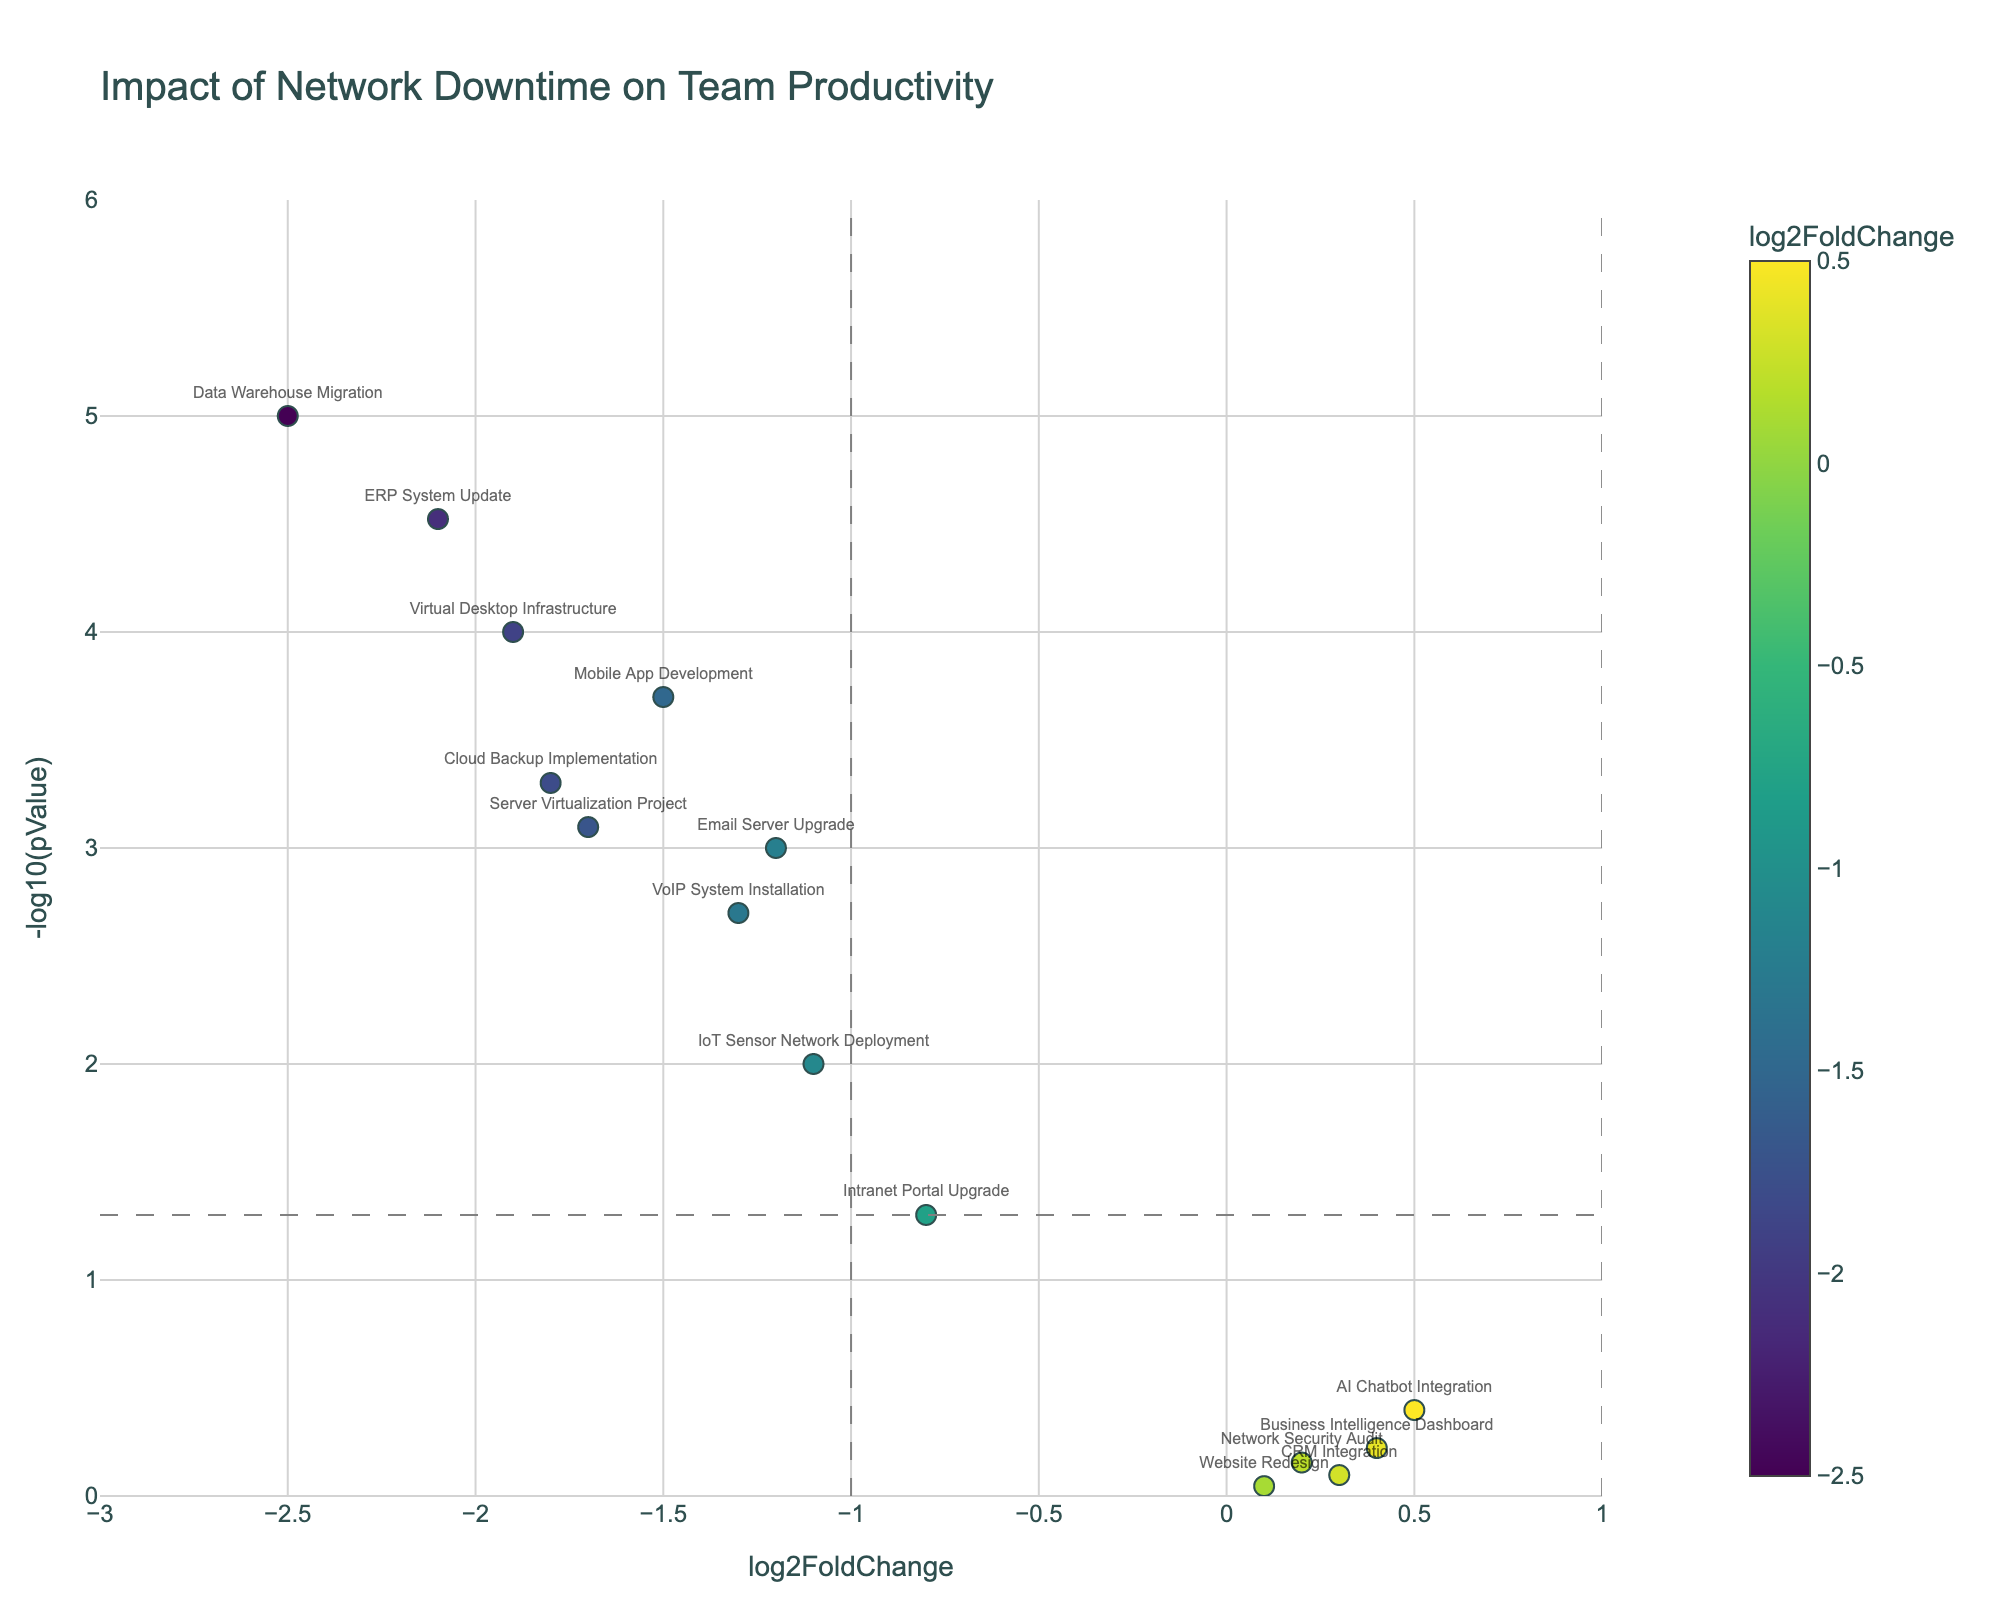How many projects are represented in the figure? Count the markers on the plot. Each marker represents one project. There are 15 markers visible on the plot.
Answer: 15 What is the title of the figure? The title is displayed at the top of the plot. It reads "Impact of Network Downtime on Team Productivity".
Answer: Impact of Network Downtime on Team Productivity Which project has the highest p-value and what is it? Look for the marker closest to the x-axis (smallest "-log10(pValue)"). The "Website Redesign" project is closest with a p-value of 0.9.
Answer: Website Redesign, 0.9 Which project shows the largest negative log2FoldChange? Identify the marker farthest to the left on the x-axis. The "Data Warehouse Migration" has the largest negative log2FoldChange at -2.5.
Answer: Data Warehouse Migration How many projects have a significant p-value below 0.05? Count the markers above the horizontal line at y = 1.3 in "-log10(pValue)". There are 10 markers above this line.
Answer: 10 Which project is both highly significant (p-value below 0.05) and has a small log2FoldChange close to zero? Locate markers above the y = 1.3 line but close to the center (x = 0). The "IoT Sensor Network Deployment" meets these criteria.
Answer: IoT Sensor Network Deployment Which project is labeled with the highest positive log2FoldChange? Locate the marker farthest to the right on the x-axis. The "AI Chatbot Integration" shows the highest positive log2FoldChange at 0.5.
Answer: AI Chatbot Integration What is the log2FoldChange and p-value for "Server Virtualization Project"? Find the marker labeled "Server Virtualization Project" and read the hovertext. The log2FoldChange is -1.7, and the p-value is 0.0008.
Answer: -1.7, 0.0008 Are there more projects with log2FoldChange less than -1 or more than -1? Count the number of markers to the left of x = -1 and compare to the count to the right of x = -1. There are 9 projects with log2FoldChange less than -1, which is more than the others.
Answer: Less than -1 Which project falls just under the significance threshold (p-value near 0.05) but does not reach it? Identify the marker just below the horizontal line at y = 1.3. "Intranet Portal Upgrade" falls just under with a p-value of 0.05.
Answer: Intranet Portal Upgrade 